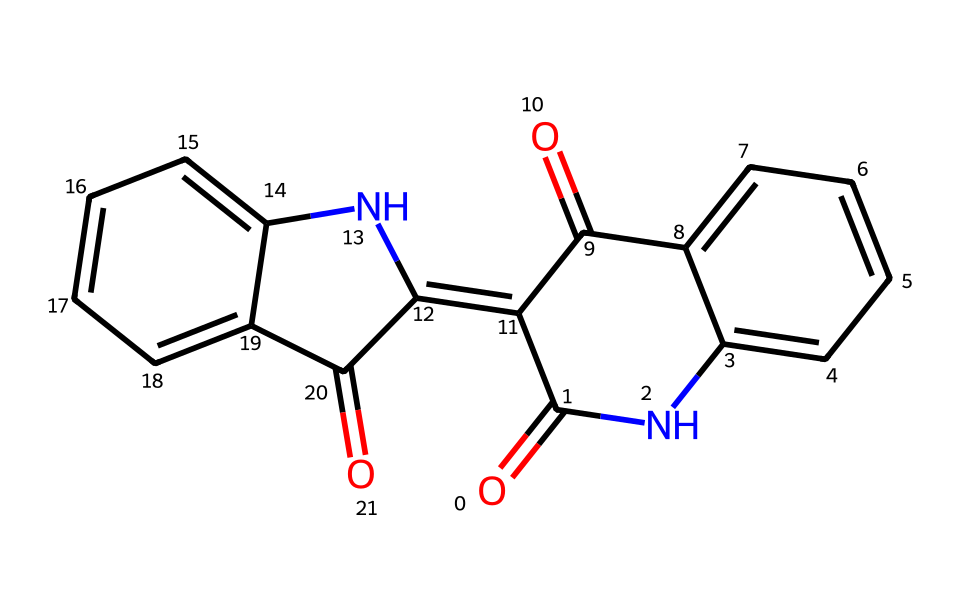What is the molecular formula of this chemical? To deduce the molecular formula, we can analyze the SMILES representation to count each type of atom present. The structure shows two carbonyl (C=O) groups and nitrogen atoms (N), along with carbon (C) atoms connected in a ring structure. Counting the atoms results in a total of 15 carbon atoms, 8 hydrogen atoms, 4 oxygen atoms, and 2 nitrogen atoms, leading to the formula C15H8N2O4.
Answer: C15H8N2O4 How many rings are present in the structure? The number of rings can be assessed by observing the arrangement of the carbon atoms. The structure includes fused benzene rings (shown by the presence of 'c' in the SMILES which indicates aromatic carbon atoms), indicating that there are two fused rings. Therefore, we can conclude that there are 2 rings in the structure.
Answer: 2 What type of chemical bond is primarily present in this structure? We can examine the connections between atoms in the SMILES to determine the predominant bond type. The structure contains multiple double bonds (C=O and C=C) alongside single bonds, suggesting a presence of covalent bonds. However, given the presence of the carbonyl groups, the prominent type is double bonds.
Answer: double bonds What functional groups can be identified in this chemical? The structure can be analyzed for specific groups of atoms that behave similarly and confer characteristic properties. Upon examining the structure, we find carbonyl (C=O) and amide groups (indicated by -C(=O)N-), identifying them as the main functional groups present.
Answer: carbonyl and amide Is this compound likely to be soluble in water? The ability of a compound to dissolve in water can be inferred from its functional groups. The presence of multiple polar groups, such as carbonyls and amides, suggests that this compound could have some degree of solubility due to potential hydrogen bonding with water. Given its complex aromatic structure, while it may exhibit some solubility, it is likely limited.
Answer: possibly limited solubility What kind of derivatives might be derived from this compound? The potential derivatives can be identified by considering modifications that could be made to the structure. Given the presence of accessible functional groups like the carbonyl and amide, derivatives could include acetylation or variations in the amine substituents, leading to a variety of substituted compounds.
Answer: acetylation and substitutions 